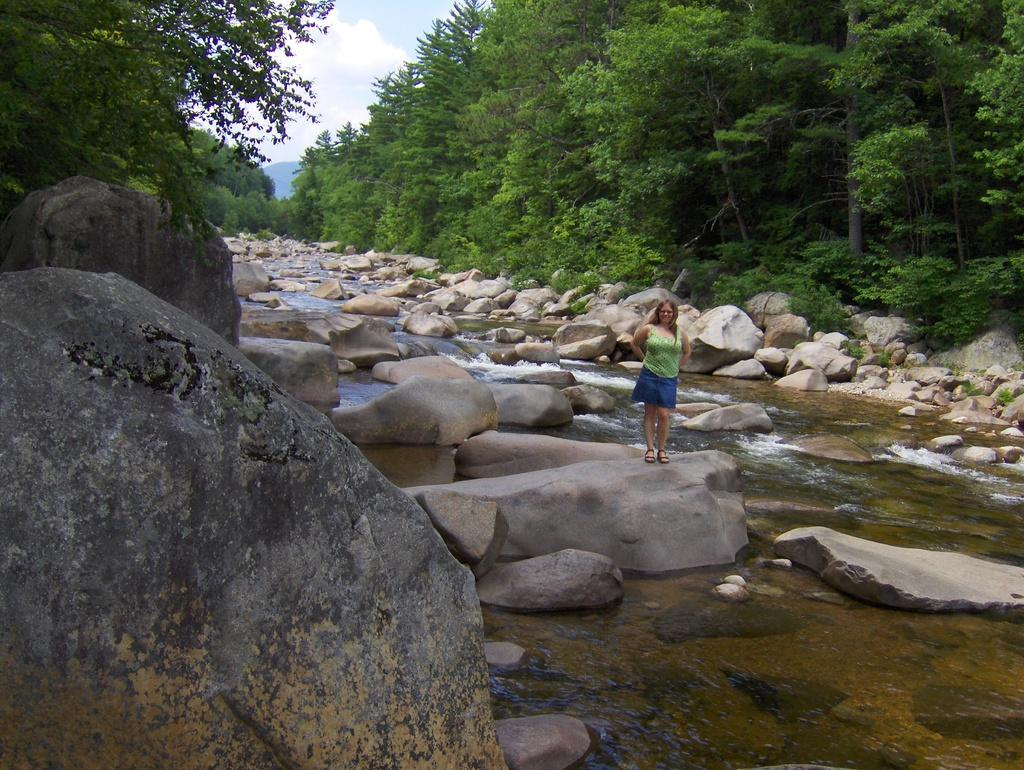Who is present in the image? There is a woman in the image. What is the woman wearing? The woman is wearing a green top and blue shorts. Where is the woman standing? The woman is standing on a rock. What is the rock placed in? The rock is placed in a lake. What can be seen in the background of the image? There is a group of stones and trees in the background of the image. How would you describe the sky in the image? The sky is cloudy in the background of the image. What is the woman's relation to the porter in the image? There is no porter present in the image, so it is not possible to determine the woman's relation to a porter. 